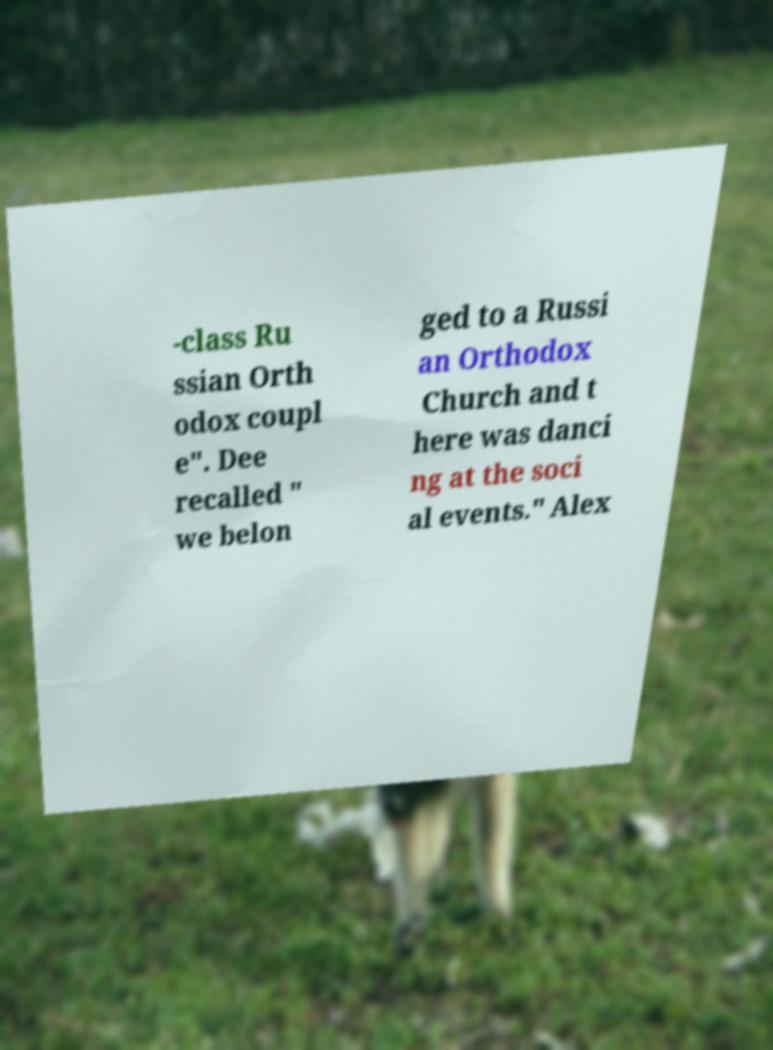Please identify and transcribe the text found in this image. -class Ru ssian Orth odox coupl e". Dee recalled " we belon ged to a Russi an Orthodox Church and t here was danci ng at the soci al events." Alex 